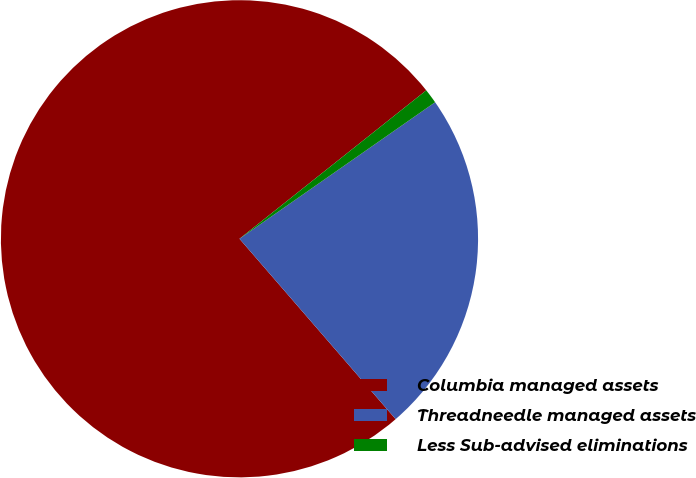<chart> <loc_0><loc_0><loc_500><loc_500><pie_chart><fcel>Columbia managed assets<fcel>Threadneedle managed assets<fcel>Less Sub-advised eliminations<nl><fcel>75.67%<fcel>23.34%<fcel>0.99%<nl></chart> 